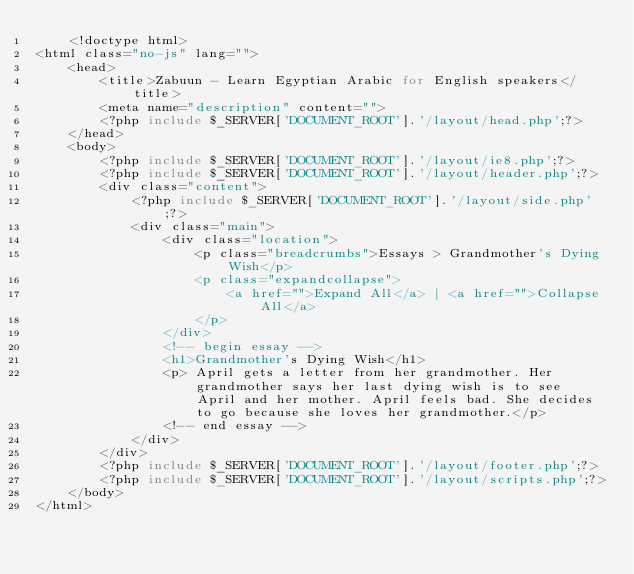<code> <loc_0><loc_0><loc_500><loc_500><_PHP_>    <!doctype html>
<html class="no-js" lang="">
	<head>
		<title>Zabuun - Learn Egyptian Arabic for English speakers</title>
		<meta name="description" content="">
		<?php include $_SERVER['DOCUMENT_ROOT'].'/layout/head.php';?>
	</head>
	<body>
		<?php include $_SERVER['DOCUMENT_ROOT'].'/layout/ie8.php';?>
		<?php include $_SERVER['DOCUMENT_ROOT'].'/layout/header.php';?>
		<div class="content">
			<?php include $_SERVER['DOCUMENT_ROOT'].'/layout/side.php';?>
			<div class="main">
				<div class="location">
					<p class="breadcrumbs">Essays > Grandmother's Dying Wish</p>
					<p class="expandcollapse">
						<a href="">Expand All</a> | <a href="">Collapse All</a>
					</p>
				</div>
				<!-- begin essay -->
				<h1>Grandmother's Dying Wish</h1>
				<p> April gets a letter from her grandmother. Her grandmother says her last dying wish is to see April and her mother. April feels bad. She decides to go because she loves her grandmother.</p>
				<!-- end essay -->
			</div>
		</div>
		<?php include $_SERVER['DOCUMENT_ROOT'].'/layout/footer.php';?>
		<?php include $_SERVER['DOCUMENT_ROOT'].'/layout/scripts.php';?>
	</body>
</html></code> 